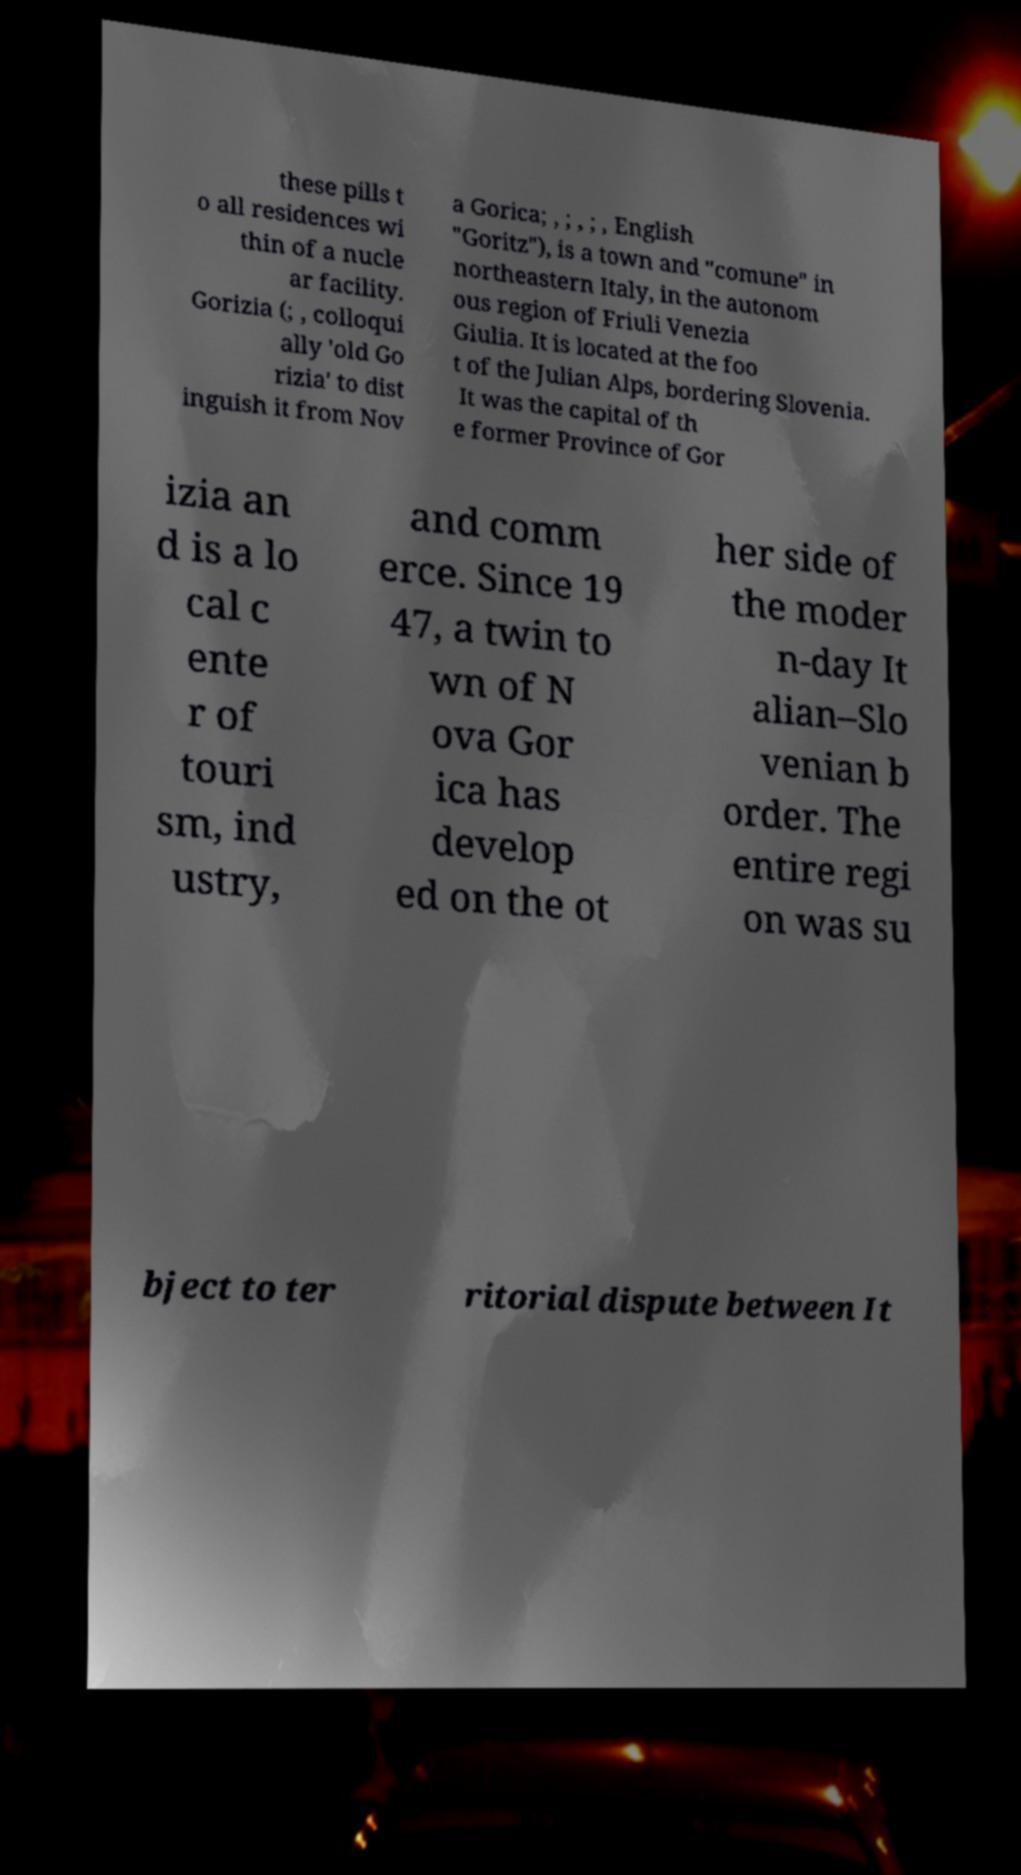Please identify and transcribe the text found in this image. these pills t o all residences wi thin of a nucle ar facility. Gorizia (; , colloqui ally 'old Go rizia' to dist inguish it from Nov a Gorica; , ; , ; , English "Goritz"), is a town and "comune" in northeastern Italy, in the autonom ous region of Friuli Venezia Giulia. It is located at the foo t of the Julian Alps, bordering Slovenia. It was the capital of th e former Province of Gor izia an d is a lo cal c ente r of touri sm, ind ustry, and comm erce. Since 19 47, a twin to wn of N ova Gor ica has develop ed on the ot her side of the moder n-day It alian–Slo venian b order. The entire regi on was su bject to ter ritorial dispute between It 